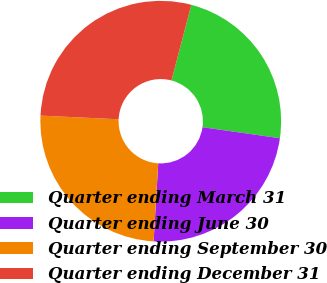Convert chart to OTSL. <chart><loc_0><loc_0><loc_500><loc_500><pie_chart><fcel>Quarter ending March 31<fcel>Quarter ending June 30<fcel>Quarter ending September 30<fcel>Quarter ending December 31<nl><fcel>23.17%<fcel>23.69%<fcel>24.8%<fcel>28.34%<nl></chart> 